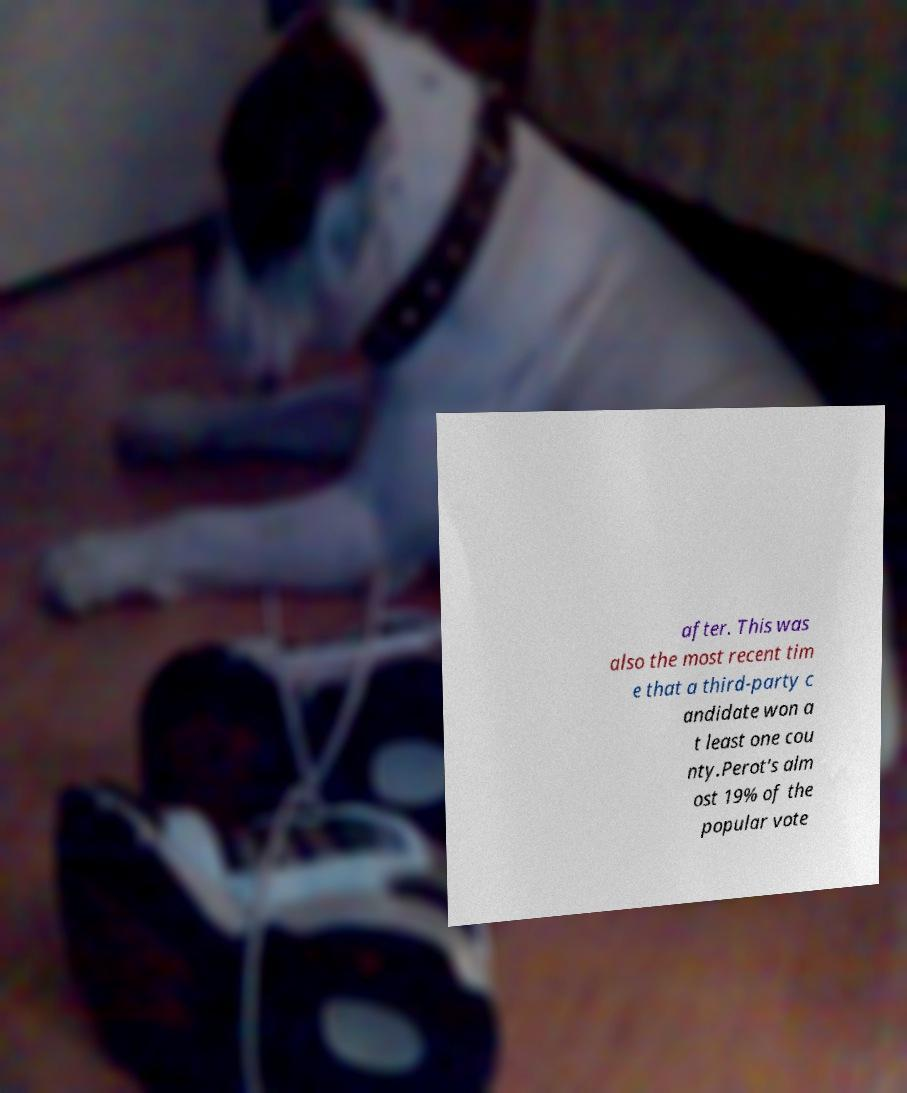For documentation purposes, I need the text within this image transcribed. Could you provide that? after. This was also the most recent tim e that a third-party c andidate won a t least one cou nty.Perot's alm ost 19% of the popular vote 